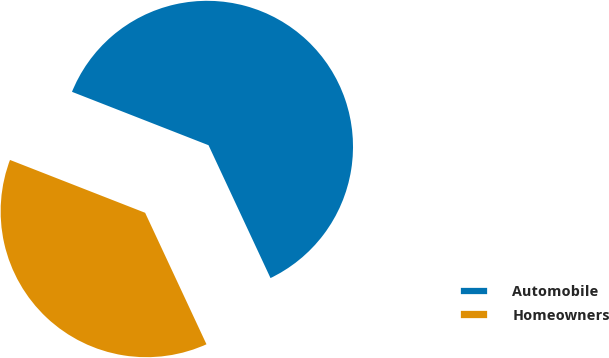<chart> <loc_0><loc_0><loc_500><loc_500><pie_chart><fcel>Automobile<fcel>Homeowners<nl><fcel>62.12%<fcel>37.88%<nl></chart> 